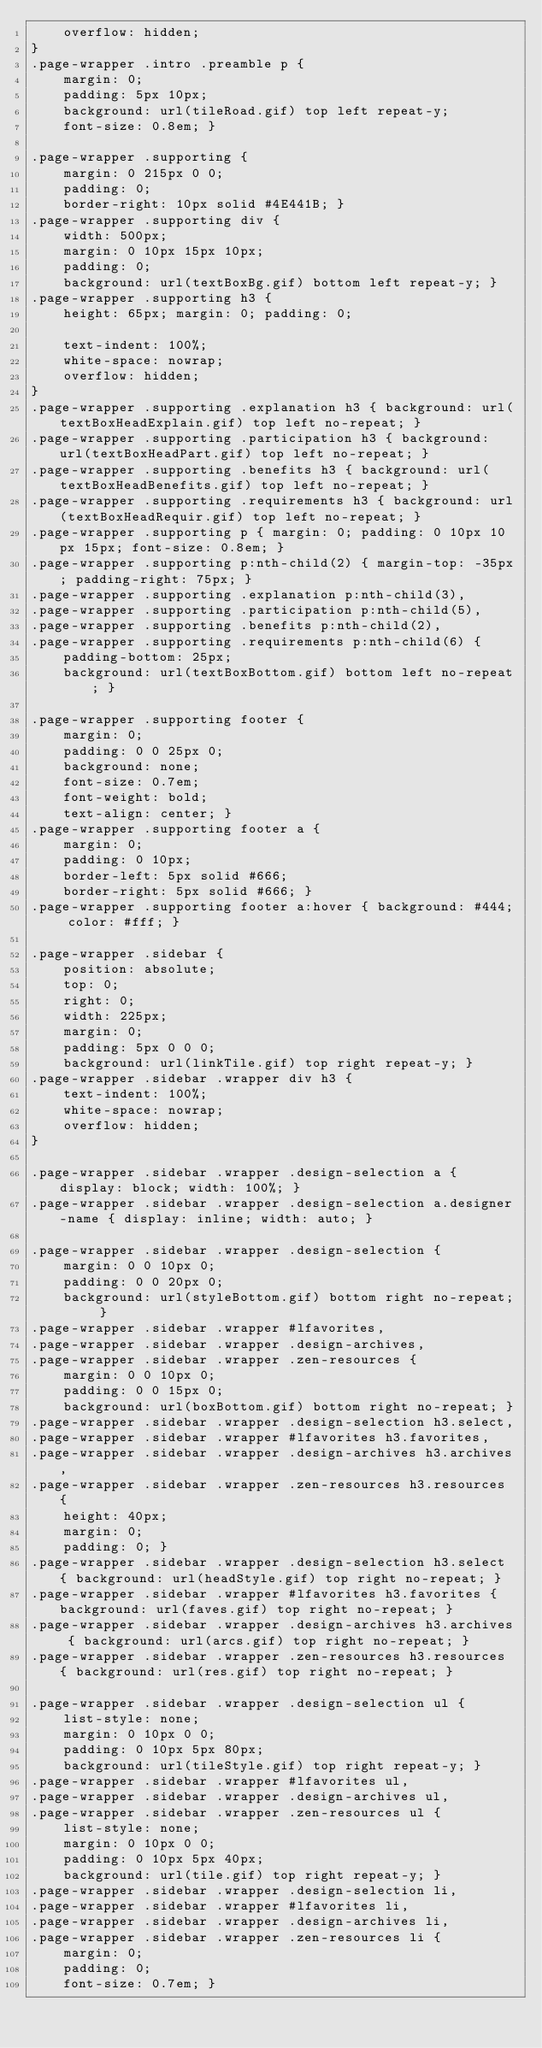<code> <loc_0><loc_0><loc_500><loc_500><_CSS_>	overflow: hidden;
}
.page-wrapper .intro .preamble p {
	margin: 0;
	padding: 5px 10px;
	background: url(tileRoad.gif) top left repeat-y;
	font-size: 0.8em; }

.page-wrapper .supporting {
	margin: 0 215px 0 0;
	padding: 0;
	border-right: 10px solid #4E441B; }
.page-wrapper .supporting div {
	width: 500px;
	margin: 0 10px 15px 10px;
	padding: 0;
	background: url(textBoxBg.gif) bottom left repeat-y; }
.page-wrapper .supporting h3 {
	height: 65px; margin: 0; padding: 0;

	text-indent: 100%;
	white-space: nowrap;
	overflow: hidden;
}
.page-wrapper .supporting .explanation h3 { background: url(textBoxHeadExplain.gif) top left no-repeat; }
.page-wrapper .supporting .participation h3 { background: url(textBoxHeadPart.gif) top left no-repeat; }
.page-wrapper .supporting .benefits h3 { background: url(textBoxHeadBenefits.gif) top left no-repeat; }
.page-wrapper .supporting .requirements h3 { background: url(textBoxHeadRequir.gif) top left no-repeat; }
.page-wrapper .supporting p { margin: 0; padding: 0 10px 10px 15px; font-size: 0.8em; }
.page-wrapper .supporting p:nth-child(2) { margin-top: -35px; padding-right: 75px; }
.page-wrapper .supporting .explanation p:nth-child(3),
.page-wrapper .supporting .participation p:nth-child(5),
.page-wrapper .supporting .benefits p:nth-child(2),
.page-wrapper .supporting .requirements p:nth-child(6) {
	padding-bottom: 25px;
	background: url(textBoxBottom.gif) bottom left no-repeat; }

.page-wrapper .supporting footer {
	margin: 0;
	padding: 0 0 25px 0;
	background: none;
	font-size: 0.7em;
	font-weight: bold;
	text-align: center; }
.page-wrapper .supporting footer a {
	margin: 0;
	padding: 0 10px;
	border-left: 5px solid #666;
	border-right: 5px solid #666; }
.page-wrapper .supporting footer a:hover { background: #444; color: #fff; }

.page-wrapper .sidebar {
	position: absolute;
	top: 0;
	right: 0;
	width: 225px;
	margin: 0;
	padding: 5px 0 0 0;
	background: url(linkTile.gif) top right repeat-y; }
.page-wrapper .sidebar .wrapper div h3 {
	text-indent: 100%;
	white-space: nowrap;
	overflow: hidden;
}

.page-wrapper .sidebar .wrapper .design-selection a { display: block; width: 100%; }
.page-wrapper .sidebar .wrapper .design-selection a.designer-name { display: inline; width: auto; }

.page-wrapper .sidebar .wrapper .design-selection {
	margin: 0 0 10px 0;
	padding: 0 0 20px 0;
	background: url(styleBottom.gif) bottom right no-repeat; }
.page-wrapper .sidebar .wrapper #lfavorites,
.page-wrapper .sidebar .wrapper .design-archives,
.page-wrapper .sidebar .wrapper .zen-resources {
	margin: 0 0 10px 0;
	padding: 0 0 15px 0;
	background: url(boxBottom.gif) bottom right no-repeat; }
.page-wrapper .sidebar .wrapper .design-selection h3.select,
.page-wrapper .sidebar .wrapper #lfavorites h3.favorites,
.page-wrapper .sidebar .wrapper .design-archives h3.archives,
.page-wrapper .sidebar .wrapper .zen-resources h3.resources {
	height: 40px;
	margin: 0;
	padding: 0; }
.page-wrapper .sidebar .wrapper .design-selection h3.select { background: url(headStyle.gif) top right no-repeat; }
.page-wrapper .sidebar .wrapper #lfavorites h3.favorites { background: url(faves.gif) top right no-repeat; }
.page-wrapper .sidebar .wrapper .design-archives h3.archives { background: url(arcs.gif) top right no-repeat; }
.page-wrapper .sidebar .wrapper .zen-resources h3.resources { background: url(res.gif) top right no-repeat; }

.page-wrapper .sidebar .wrapper .design-selection ul {
	list-style: none;
	margin: 0 10px 0 0;
	padding: 0 10px 5px 80px;
	background: url(tileStyle.gif) top right repeat-y; }
.page-wrapper .sidebar .wrapper #lfavorites ul,
.page-wrapper .sidebar .wrapper .design-archives ul,
.page-wrapper .sidebar .wrapper .zen-resources ul {
	list-style: none;
	margin: 0 10px 0 0;
	padding: 0 10px 5px 40px;
	background: url(tile.gif) top right repeat-y; }
.page-wrapper .sidebar .wrapper .design-selection li,
.page-wrapper .sidebar .wrapper #lfavorites li,
.page-wrapper .sidebar .wrapper .design-archives li,
.page-wrapper .sidebar .wrapper .zen-resources li {
	margin: 0;
	padding: 0;
	font-size: 0.7em; }</code> 